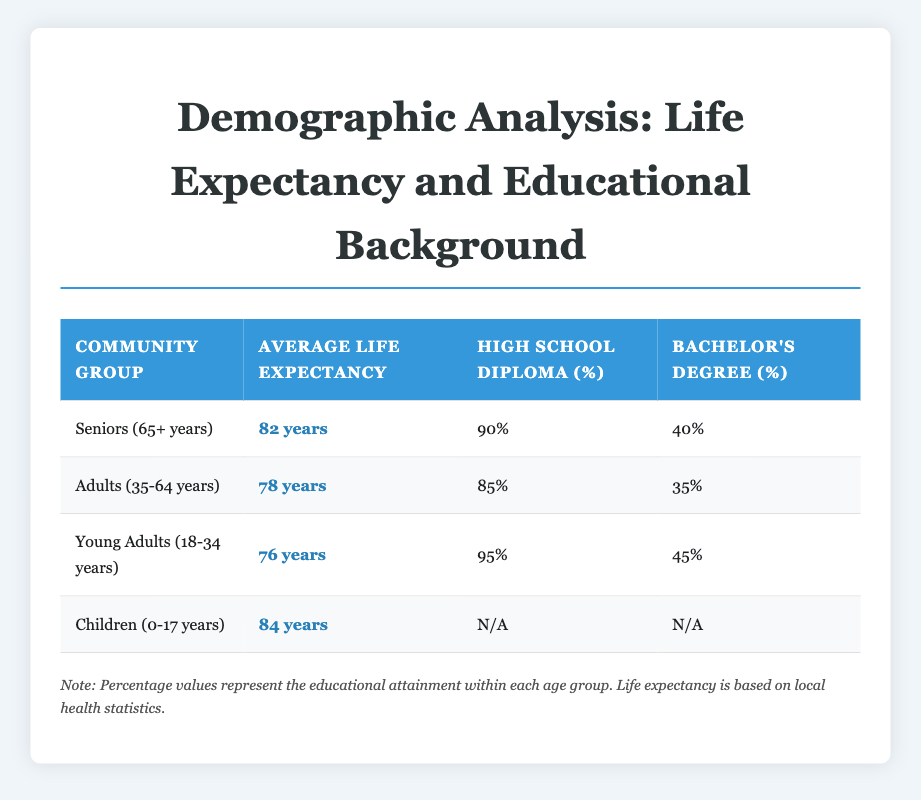What's the average life expectancy for Seniors (65+ years)? The table indicates that the average life expectancy for Seniors (65+ years) is listed directly as 82 years.
Answer: 82 years What percentage of Adults (35-64 years) have a Bachelor's Degree? The table shows that 35% of Adults (35-64 years) have a Bachelor's Degree, which is a specific value provided in the educational attainment column.
Answer: 35% Which community group has the highest percentage of high school diploma holders? By comparing the percentages, we see that Young Adults (18-34 years) have 95%, which is higher than the other groups (90%, 85%, and not applicable for Children).
Answer: Young Adults (18-34 years) How many years longer do Seniors (65+ years) live on average compared to Young Adults (18-34 years)? To find the difference, subtract the average life expectancy of Young Adults (76 years) from that of Seniors (82 years): 82 - 76 = 6 years.
Answer: 6 years Is it true that Children (0-17 years) have the highest life expectancy among all age groups listed? The average life expectancy for Children (84 years) is higher than that of Adults (78 years) and Young Adults (76 years) but lower than Seniors (82 years). Therefore, it is false that Children have the highest life expectancy.
Answer: No If you were to rank the community groups by their average life expectancy from highest to lowest, what would the order be? By looking at the average life expectancy values—Children (84 years), Seniors (82 years), Adults (78 years), and Young Adults (76 years)—the ranking is: Children, Seniors, Adults, Young Adults.
Answer: Children, Seniors, Adults, Young Adults What is the average life expectancy of the three adult groups combined (Seniors, Adults, and Young Adults)? To calculate the average, add the life expectancies of all three groups: 82 (Seniors) + 78 (Adults) + 76 (Young Adults) = 236. Then, divide by the number of groups (3): 236 / 3 = 78.67 years.
Answer: 78.67 years Do more Seniors (65+ years) have high school diplomas compared to Young Adults (18-34 years)? Yes, Seniors have 90% and Young Adults have 95%. The statement is false; clearly, Young Adults have a higher percentage.
Answer: No What percentage of Children (0-17 years) have a high school diploma? The table indicates that there is no data (N/A) for the percentage of Children (0-17 years) with a high school diploma, thus unable to provide a value.
Answer: N/A 